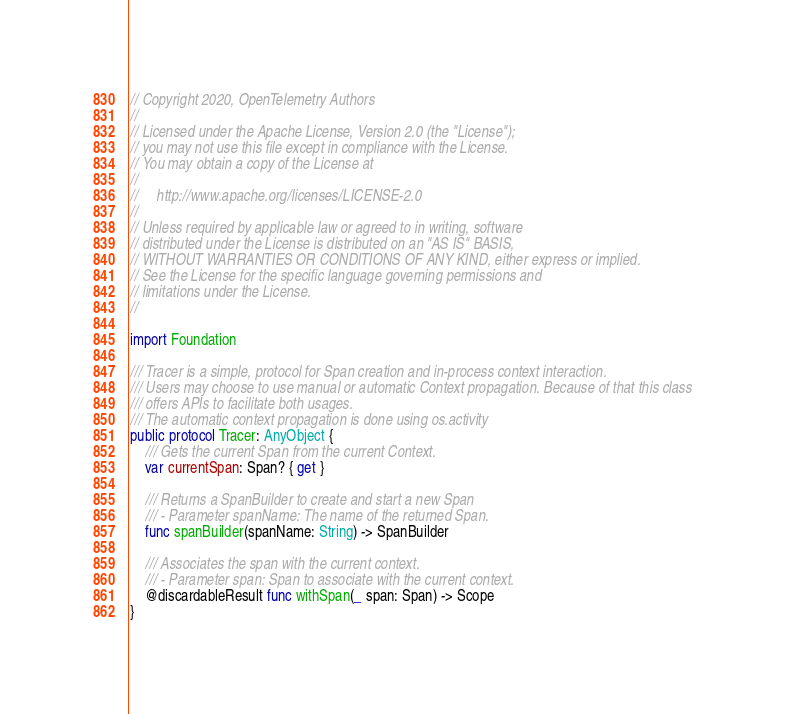<code> <loc_0><loc_0><loc_500><loc_500><_Swift_>// Copyright 2020, OpenTelemetry Authors
//
// Licensed under the Apache License, Version 2.0 (the "License");
// you may not use this file except in compliance with the License.
// You may obtain a copy of the License at
//
//     http://www.apache.org/licenses/LICENSE-2.0
//
// Unless required by applicable law or agreed to in writing, software
// distributed under the License is distributed on an "AS IS" BASIS,
// WITHOUT WARRANTIES OR CONDITIONS OF ANY KIND, either express or implied.
// See the License for the specific language governing permissions and
// limitations under the License.
//

import Foundation

/// Tracer is a simple, protocol for Span creation and in-process context interaction.
/// Users may choose to use manual or automatic Context propagation. Because of that this class
/// offers APIs to facilitate both usages.
/// The automatic context propagation is done using os.activity
public protocol Tracer: AnyObject {
    /// Gets the current Span from the current Context.
    var currentSpan: Span? { get }

    /// Returns a SpanBuilder to create and start a new Span
    /// - Parameter spanName: The name of the returned Span.
    func spanBuilder(spanName: String) -> SpanBuilder

    /// Associates the span with the current context.
    /// - Parameter span: Span to associate with the current context.
    @discardableResult func withSpan(_ span: Span) -> Scope
}
</code> 